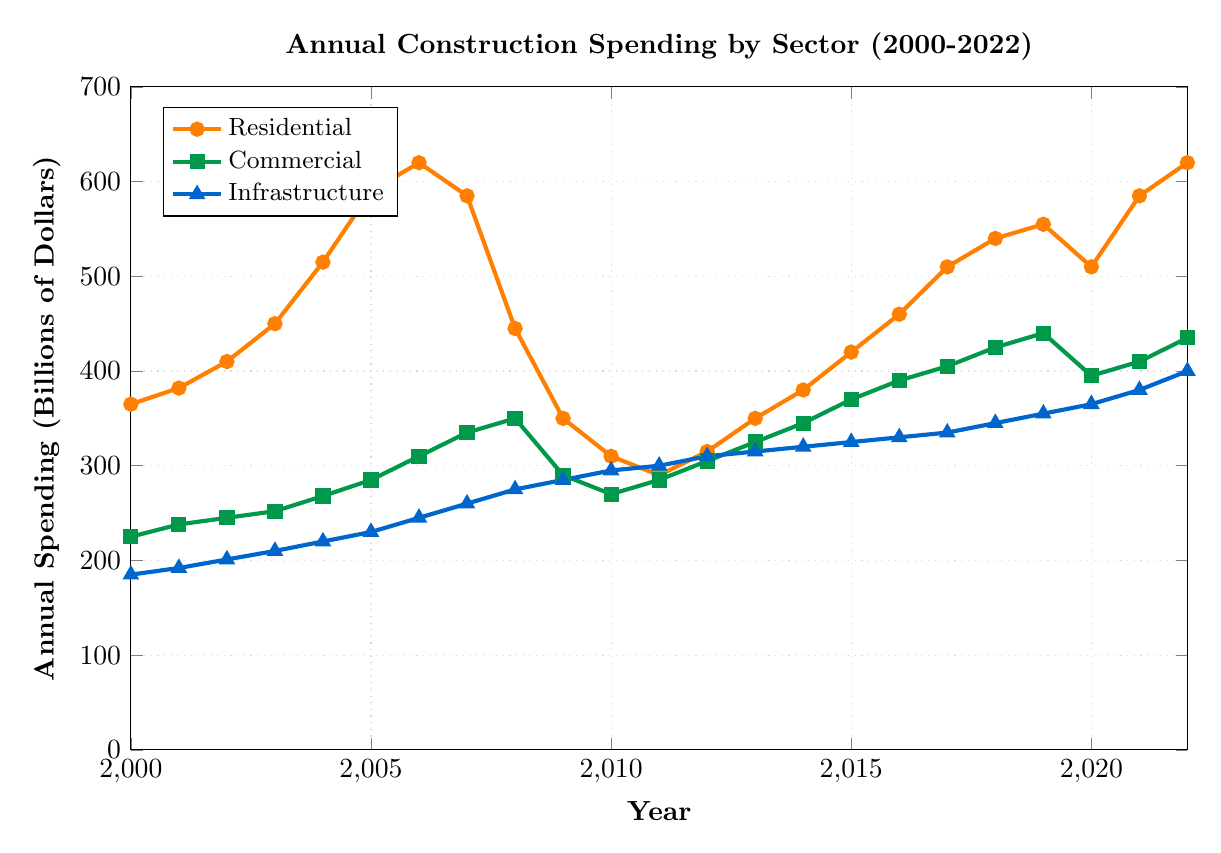When did the annual residential spending first exceed $500 billion? By observing the residential line (orange), it first crosses the $500 billion mark in the year 2004.
Answer: 2004 Which sector had the least spending in 2000? By examining the starting points of the three lines, infrastructure spending (blue) is the lowest at $185 billion compared to residential ($365 billion) and commercial ($225 billion) in 2000.
Answer: Infrastructure What was the difference in residential spending between 2006 and 2009? Residential spending in 2006 is $620 billion and in 2009 it is $350 billion. The difference is calculated as $620 billion - $350 billion = $270 billion.
Answer: $270 billion In which year did commercial spending surpass residential spending? Looking at the chart, in 2008, commercial spending (green) at $350 billion surpasses residential spending (orange) at $445 billion. By 2009, commercial ($290 billion) is above residential ($350 billion).
Answer: 2008 What is the sum of infrastructure spending from 2015 to 2017? Infrastructure spending is $325 billion in 2015, $330 billion in 2016, and $335 billion in 2017. Summing these values gives $325 billion + $330 billion + $335 billion = $990 billion.
Answer: $990 billion How did commercial spending change from 2020 to 2021? Commercial spending in 2020 is $395 billion and it increases to $410 billion in 2021. Therefore, the change is an increase of $410 billion - $395 billion = $15 billion.
Answer: Increased by $15 billion Between 2012 and 2022, in which year did infrastructure spending see the steepest increase? By observing the blue infrastructure line, the steepest increase occurs between 2019 and 2020, where spending jumps from $355 billion to $365 billion, an increase of $10 billion.
Answer: 2019-2020 Compare the trends in residential and infrastructure spending from 2007 to 2010. From 2007 to 2010, residential spending (orange) shows a significant decline from $585 billion to $310 billion, while infrastructure spending (blue) gradually increases from $260 billion to $295 billion.
Answer: Residential declines, Infrastructure increases What was the average annual residential spending from 2000 to 2010? Sum the residential spending from 2000 ($365 billion) to 2010 ($310 billion) and divide by 11 (number of years). The sum = $365 + $382 + $410 + $450 + $515 + $590 + $620 + $585 + $445 + $350 + $310 = $5022 billion. The average is $5022 billion / 11 = approximately $456 billion.
Answer: Approximately $456 billion Which sector showed the highest spending in 2022? Observing the ending points of the lines in 2022, residential spending (orange) at $620 billion is highest compared to commercial ($435 billion) and infrastructure ($400 billion).
Answer: Residential 